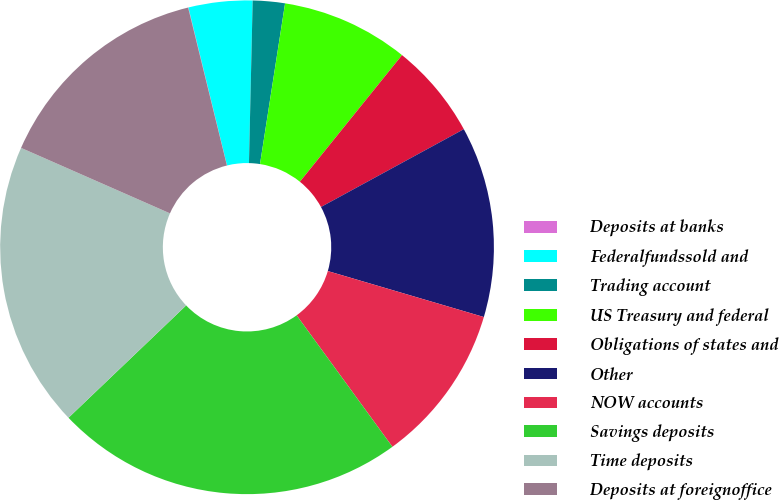Convert chart. <chart><loc_0><loc_0><loc_500><loc_500><pie_chart><fcel>Deposits at banks<fcel>Federalfundssold and<fcel>Trading account<fcel>US Treasury and federal<fcel>Obligations of states and<fcel>Other<fcel>NOW accounts<fcel>Savings deposits<fcel>Time deposits<fcel>Deposits at foreignoffice<nl><fcel>0.02%<fcel>4.18%<fcel>2.1%<fcel>8.34%<fcel>6.26%<fcel>12.5%<fcel>10.42%<fcel>22.89%<fcel>18.73%<fcel>14.57%<nl></chart> 